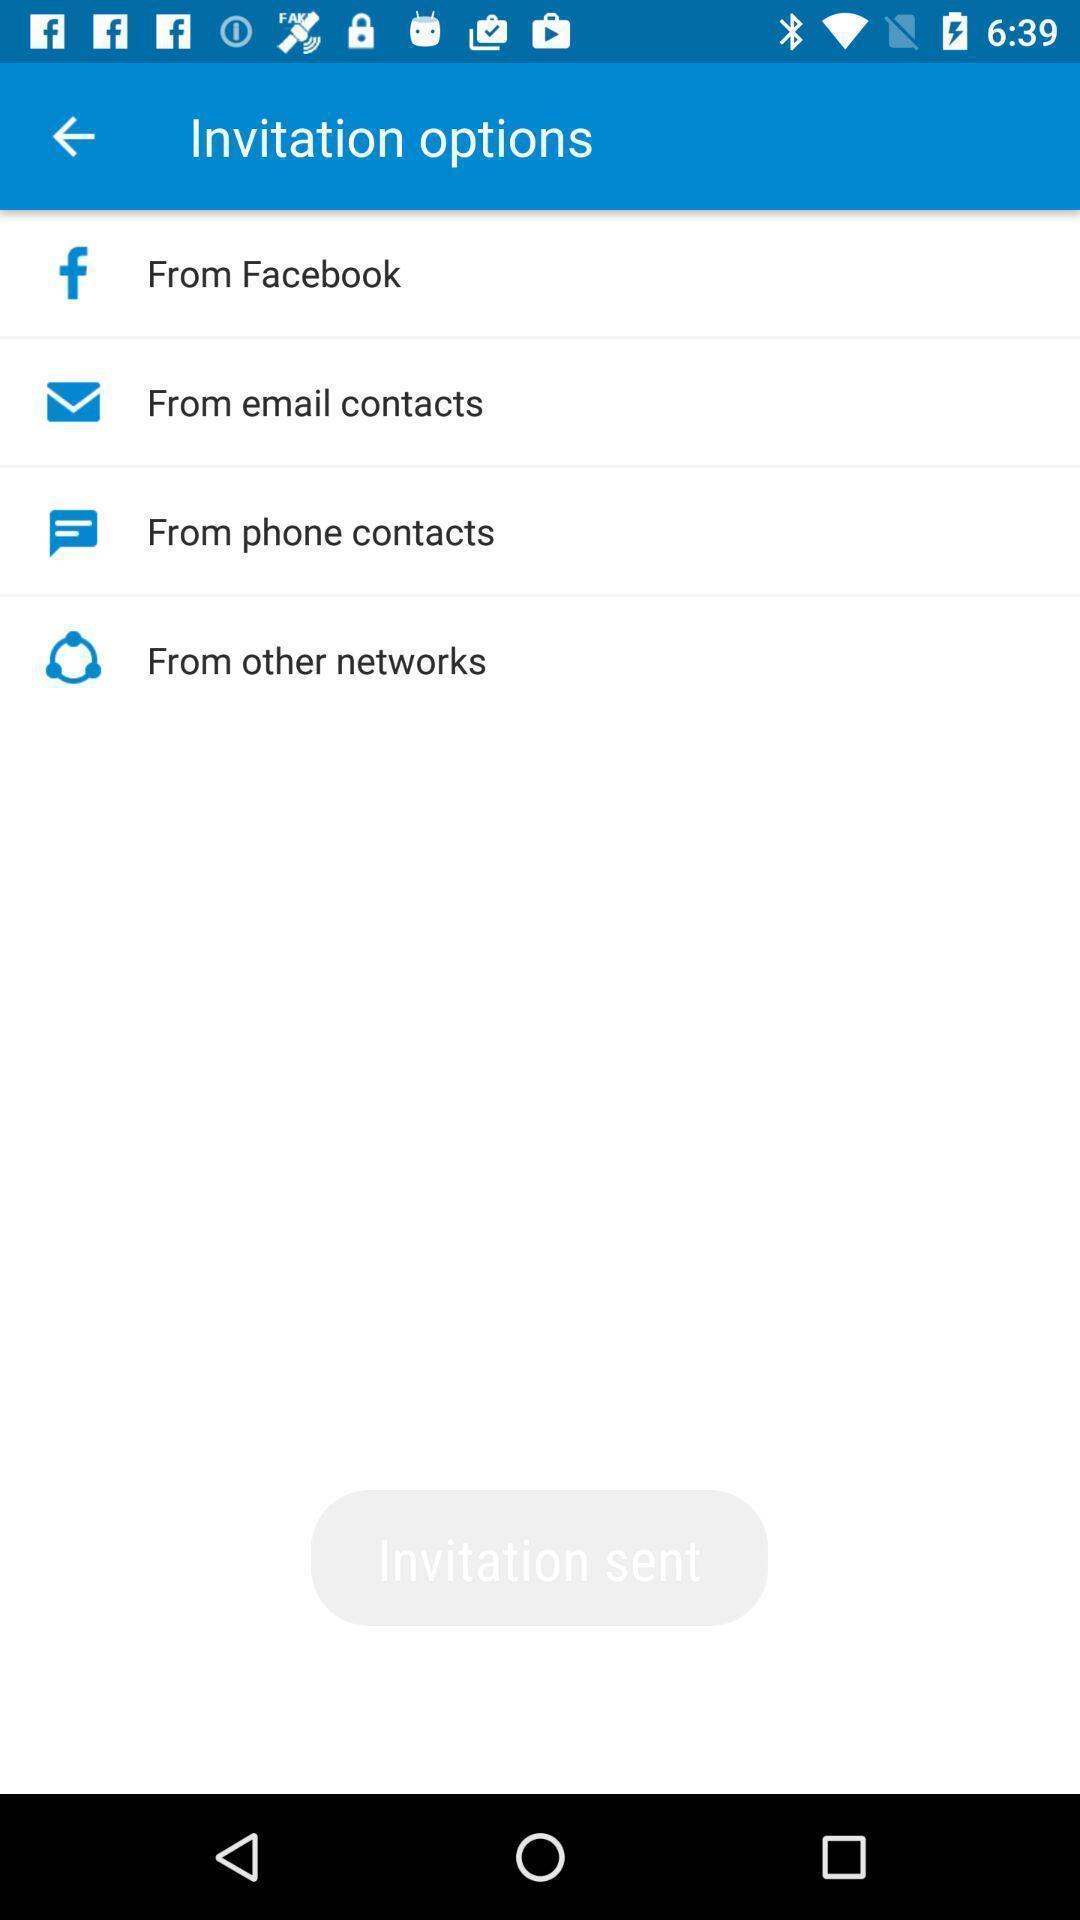Provide a textual representation of this image. Screen showing invitation options. 